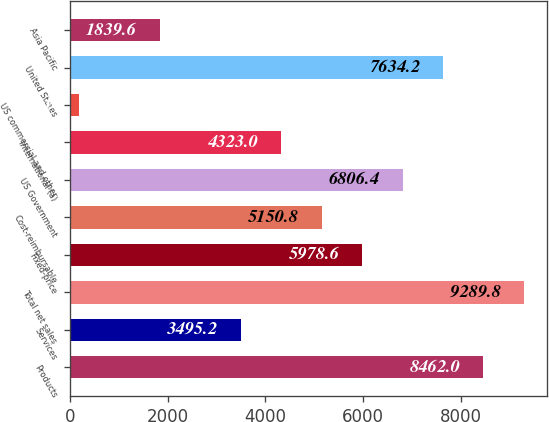Convert chart to OTSL. <chart><loc_0><loc_0><loc_500><loc_500><bar_chart><fcel>Products<fcel>Services<fcel>Total net sales<fcel>Fixed-price<fcel>Cost-reimbursable<fcel>US Government<fcel>International (a)<fcel>US commercial and other<fcel>United States<fcel>Asia Pacific<nl><fcel>8462<fcel>3495.2<fcel>9289.8<fcel>5978.6<fcel>5150.8<fcel>6806.4<fcel>4323<fcel>184<fcel>7634.2<fcel>1839.6<nl></chart> 